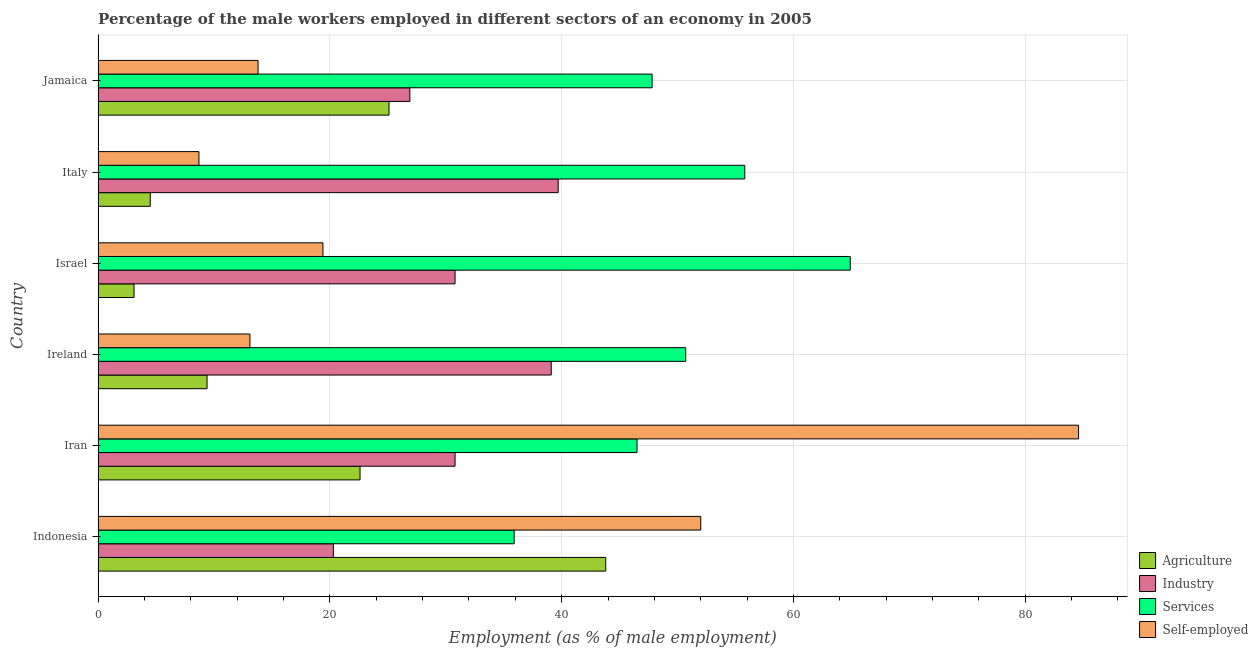How many different coloured bars are there?
Your answer should be very brief. 4. Are the number of bars per tick equal to the number of legend labels?
Ensure brevity in your answer.  Yes. How many bars are there on the 2nd tick from the bottom?
Provide a short and direct response. 4. What is the label of the 2nd group of bars from the top?
Give a very brief answer. Italy. In how many cases, is the number of bars for a given country not equal to the number of legend labels?
Give a very brief answer. 0. What is the percentage of male workers in services in Jamaica?
Keep it short and to the point. 47.8. Across all countries, what is the maximum percentage of male workers in agriculture?
Your answer should be very brief. 43.8. Across all countries, what is the minimum percentage of male workers in industry?
Give a very brief answer. 20.3. In which country was the percentage of male workers in industry maximum?
Offer a very short reply. Italy. In which country was the percentage of male workers in services minimum?
Make the answer very short. Indonesia. What is the total percentage of male workers in services in the graph?
Provide a short and direct response. 301.6. What is the difference between the percentage of male workers in agriculture in Indonesia and that in Iran?
Provide a short and direct response. 21.2. What is the difference between the percentage of male workers in agriculture in Iran and the percentage of male workers in services in Israel?
Give a very brief answer. -42.3. What is the average percentage of male workers in industry per country?
Your answer should be very brief. 31.27. What is the difference between the percentage of male workers in agriculture and percentage of self employed male workers in Iran?
Provide a succinct answer. -62. In how many countries, is the percentage of male workers in services greater than 52 %?
Make the answer very short. 2. What is the ratio of the percentage of male workers in services in Ireland to that in Israel?
Your answer should be very brief. 0.78. Is the difference between the percentage of male workers in agriculture in Indonesia and Jamaica greater than the difference between the percentage of male workers in industry in Indonesia and Jamaica?
Keep it short and to the point. Yes. What is the difference between the highest and the second highest percentage of male workers in industry?
Provide a succinct answer. 0.6. What is the difference between the highest and the lowest percentage of male workers in industry?
Provide a succinct answer. 19.4. What does the 4th bar from the top in Iran represents?
Keep it short and to the point. Agriculture. What does the 4th bar from the bottom in Jamaica represents?
Your answer should be very brief. Self-employed. Is it the case that in every country, the sum of the percentage of male workers in agriculture and percentage of male workers in industry is greater than the percentage of male workers in services?
Provide a succinct answer. No. How many bars are there?
Offer a terse response. 24. Are all the bars in the graph horizontal?
Give a very brief answer. Yes. What is the difference between two consecutive major ticks on the X-axis?
Give a very brief answer. 20. How many legend labels are there?
Ensure brevity in your answer.  4. What is the title of the graph?
Your response must be concise. Percentage of the male workers employed in different sectors of an economy in 2005. Does "Taxes on income" appear as one of the legend labels in the graph?
Your answer should be very brief. No. What is the label or title of the X-axis?
Provide a succinct answer. Employment (as % of male employment). What is the Employment (as % of male employment) in Agriculture in Indonesia?
Your answer should be very brief. 43.8. What is the Employment (as % of male employment) in Industry in Indonesia?
Make the answer very short. 20.3. What is the Employment (as % of male employment) of Services in Indonesia?
Keep it short and to the point. 35.9. What is the Employment (as % of male employment) in Self-employed in Indonesia?
Keep it short and to the point. 52. What is the Employment (as % of male employment) of Agriculture in Iran?
Offer a terse response. 22.6. What is the Employment (as % of male employment) of Industry in Iran?
Give a very brief answer. 30.8. What is the Employment (as % of male employment) in Services in Iran?
Your response must be concise. 46.5. What is the Employment (as % of male employment) in Self-employed in Iran?
Give a very brief answer. 84.6. What is the Employment (as % of male employment) of Agriculture in Ireland?
Offer a very short reply. 9.4. What is the Employment (as % of male employment) of Industry in Ireland?
Provide a succinct answer. 39.1. What is the Employment (as % of male employment) in Services in Ireland?
Ensure brevity in your answer.  50.7. What is the Employment (as % of male employment) of Self-employed in Ireland?
Provide a short and direct response. 13.1. What is the Employment (as % of male employment) in Agriculture in Israel?
Give a very brief answer. 3.1. What is the Employment (as % of male employment) in Industry in Israel?
Ensure brevity in your answer.  30.8. What is the Employment (as % of male employment) of Services in Israel?
Ensure brevity in your answer.  64.9. What is the Employment (as % of male employment) in Self-employed in Israel?
Your answer should be very brief. 19.4. What is the Employment (as % of male employment) of Agriculture in Italy?
Make the answer very short. 4.5. What is the Employment (as % of male employment) of Industry in Italy?
Your response must be concise. 39.7. What is the Employment (as % of male employment) in Services in Italy?
Your answer should be compact. 55.8. What is the Employment (as % of male employment) of Self-employed in Italy?
Offer a very short reply. 8.7. What is the Employment (as % of male employment) of Agriculture in Jamaica?
Offer a terse response. 25.1. What is the Employment (as % of male employment) in Industry in Jamaica?
Offer a terse response. 26.9. What is the Employment (as % of male employment) in Services in Jamaica?
Your answer should be compact. 47.8. What is the Employment (as % of male employment) in Self-employed in Jamaica?
Your answer should be compact. 13.8. Across all countries, what is the maximum Employment (as % of male employment) of Agriculture?
Give a very brief answer. 43.8. Across all countries, what is the maximum Employment (as % of male employment) in Industry?
Provide a short and direct response. 39.7. Across all countries, what is the maximum Employment (as % of male employment) of Services?
Ensure brevity in your answer.  64.9. Across all countries, what is the maximum Employment (as % of male employment) of Self-employed?
Your answer should be very brief. 84.6. Across all countries, what is the minimum Employment (as % of male employment) of Agriculture?
Ensure brevity in your answer.  3.1. Across all countries, what is the minimum Employment (as % of male employment) in Industry?
Provide a succinct answer. 20.3. Across all countries, what is the minimum Employment (as % of male employment) of Services?
Offer a very short reply. 35.9. Across all countries, what is the minimum Employment (as % of male employment) in Self-employed?
Offer a very short reply. 8.7. What is the total Employment (as % of male employment) in Agriculture in the graph?
Your response must be concise. 108.5. What is the total Employment (as % of male employment) in Industry in the graph?
Ensure brevity in your answer.  187.6. What is the total Employment (as % of male employment) of Services in the graph?
Keep it short and to the point. 301.6. What is the total Employment (as % of male employment) of Self-employed in the graph?
Keep it short and to the point. 191.6. What is the difference between the Employment (as % of male employment) in Agriculture in Indonesia and that in Iran?
Ensure brevity in your answer.  21.2. What is the difference between the Employment (as % of male employment) of Services in Indonesia and that in Iran?
Offer a terse response. -10.6. What is the difference between the Employment (as % of male employment) in Self-employed in Indonesia and that in Iran?
Keep it short and to the point. -32.6. What is the difference between the Employment (as % of male employment) of Agriculture in Indonesia and that in Ireland?
Ensure brevity in your answer.  34.4. What is the difference between the Employment (as % of male employment) of Industry in Indonesia and that in Ireland?
Ensure brevity in your answer.  -18.8. What is the difference between the Employment (as % of male employment) of Services in Indonesia and that in Ireland?
Give a very brief answer. -14.8. What is the difference between the Employment (as % of male employment) of Self-employed in Indonesia and that in Ireland?
Your answer should be compact. 38.9. What is the difference between the Employment (as % of male employment) of Agriculture in Indonesia and that in Israel?
Provide a succinct answer. 40.7. What is the difference between the Employment (as % of male employment) in Industry in Indonesia and that in Israel?
Give a very brief answer. -10.5. What is the difference between the Employment (as % of male employment) of Services in Indonesia and that in Israel?
Your answer should be very brief. -29. What is the difference between the Employment (as % of male employment) in Self-employed in Indonesia and that in Israel?
Your response must be concise. 32.6. What is the difference between the Employment (as % of male employment) of Agriculture in Indonesia and that in Italy?
Ensure brevity in your answer.  39.3. What is the difference between the Employment (as % of male employment) of Industry in Indonesia and that in Italy?
Offer a very short reply. -19.4. What is the difference between the Employment (as % of male employment) in Services in Indonesia and that in Italy?
Give a very brief answer. -19.9. What is the difference between the Employment (as % of male employment) of Self-employed in Indonesia and that in Italy?
Keep it short and to the point. 43.3. What is the difference between the Employment (as % of male employment) in Industry in Indonesia and that in Jamaica?
Ensure brevity in your answer.  -6.6. What is the difference between the Employment (as % of male employment) of Services in Indonesia and that in Jamaica?
Your answer should be very brief. -11.9. What is the difference between the Employment (as % of male employment) of Self-employed in Indonesia and that in Jamaica?
Ensure brevity in your answer.  38.2. What is the difference between the Employment (as % of male employment) of Agriculture in Iran and that in Ireland?
Your response must be concise. 13.2. What is the difference between the Employment (as % of male employment) of Industry in Iran and that in Ireland?
Keep it short and to the point. -8.3. What is the difference between the Employment (as % of male employment) in Services in Iran and that in Ireland?
Give a very brief answer. -4.2. What is the difference between the Employment (as % of male employment) of Self-employed in Iran and that in Ireland?
Offer a very short reply. 71.5. What is the difference between the Employment (as % of male employment) in Agriculture in Iran and that in Israel?
Offer a very short reply. 19.5. What is the difference between the Employment (as % of male employment) of Industry in Iran and that in Israel?
Make the answer very short. 0. What is the difference between the Employment (as % of male employment) in Services in Iran and that in Israel?
Give a very brief answer. -18.4. What is the difference between the Employment (as % of male employment) in Self-employed in Iran and that in Israel?
Provide a succinct answer. 65.2. What is the difference between the Employment (as % of male employment) of Industry in Iran and that in Italy?
Give a very brief answer. -8.9. What is the difference between the Employment (as % of male employment) of Self-employed in Iran and that in Italy?
Ensure brevity in your answer.  75.9. What is the difference between the Employment (as % of male employment) in Agriculture in Iran and that in Jamaica?
Offer a very short reply. -2.5. What is the difference between the Employment (as % of male employment) of Industry in Iran and that in Jamaica?
Your answer should be compact. 3.9. What is the difference between the Employment (as % of male employment) in Services in Iran and that in Jamaica?
Provide a short and direct response. -1.3. What is the difference between the Employment (as % of male employment) in Self-employed in Iran and that in Jamaica?
Your answer should be compact. 70.8. What is the difference between the Employment (as % of male employment) of Agriculture in Ireland and that in Israel?
Ensure brevity in your answer.  6.3. What is the difference between the Employment (as % of male employment) of Services in Ireland and that in Israel?
Give a very brief answer. -14.2. What is the difference between the Employment (as % of male employment) of Self-employed in Ireland and that in Israel?
Provide a short and direct response. -6.3. What is the difference between the Employment (as % of male employment) in Agriculture in Ireland and that in Italy?
Your answer should be compact. 4.9. What is the difference between the Employment (as % of male employment) in Agriculture in Ireland and that in Jamaica?
Your response must be concise. -15.7. What is the difference between the Employment (as % of male employment) in Services in Israel and that in Jamaica?
Provide a succinct answer. 17.1. What is the difference between the Employment (as % of male employment) of Self-employed in Israel and that in Jamaica?
Your answer should be compact. 5.6. What is the difference between the Employment (as % of male employment) of Agriculture in Italy and that in Jamaica?
Your answer should be compact. -20.6. What is the difference between the Employment (as % of male employment) in Agriculture in Indonesia and the Employment (as % of male employment) in Industry in Iran?
Your response must be concise. 13. What is the difference between the Employment (as % of male employment) of Agriculture in Indonesia and the Employment (as % of male employment) of Services in Iran?
Provide a short and direct response. -2.7. What is the difference between the Employment (as % of male employment) of Agriculture in Indonesia and the Employment (as % of male employment) of Self-employed in Iran?
Your response must be concise. -40.8. What is the difference between the Employment (as % of male employment) in Industry in Indonesia and the Employment (as % of male employment) in Services in Iran?
Give a very brief answer. -26.2. What is the difference between the Employment (as % of male employment) in Industry in Indonesia and the Employment (as % of male employment) in Self-employed in Iran?
Provide a short and direct response. -64.3. What is the difference between the Employment (as % of male employment) of Services in Indonesia and the Employment (as % of male employment) of Self-employed in Iran?
Offer a very short reply. -48.7. What is the difference between the Employment (as % of male employment) in Agriculture in Indonesia and the Employment (as % of male employment) in Industry in Ireland?
Make the answer very short. 4.7. What is the difference between the Employment (as % of male employment) of Agriculture in Indonesia and the Employment (as % of male employment) of Services in Ireland?
Provide a short and direct response. -6.9. What is the difference between the Employment (as % of male employment) of Agriculture in Indonesia and the Employment (as % of male employment) of Self-employed in Ireland?
Your answer should be very brief. 30.7. What is the difference between the Employment (as % of male employment) in Industry in Indonesia and the Employment (as % of male employment) in Services in Ireland?
Give a very brief answer. -30.4. What is the difference between the Employment (as % of male employment) in Services in Indonesia and the Employment (as % of male employment) in Self-employed in Ireland?
Provide a succinct answer. 22.8. What is the difference between the Employment (as % of male employment) of Agriculture in Indonesia and the Employment (as % of male employment) of Industry in Israel?
Your answer should be very brief. 13. What is the difference between the Employment (as % of male employment) of Agriculture in Indonesia and the Employment (as % of male employment) of Services in Israel?
Provide a succinct answer. -21.1. What is the difference between the Employment (as % of male employment) in Agriculture in Indonesia and the Employment (as % of male employment) in Self-employed in Israel?
Offer a terse response. 24.4. What is the difference between the Employment (as % of male employment) of Industry in Indonesia and the Employment (as % of male employment) of Services in Israel?
Provide a short and direct response. -44.6. What is the difference between the Employment (as % of male employment) of Agriculture in Indonesia and the Employment (as % of male employment) of Self-employed in Italy?
Give a very brief answer. 35.1. What is the difference between the Employment (as % of male employment) of Industry in Indonesia and the Employment (as % of male employment) of Services in Italy?
Offer a very short reply. -35.5. What is the difference between the Employment (as % of male employment) in Services in Indonesia and the Employment (as % of male employment) in Self-employed in Italy?
Ensure brevity in your answer.  27.2. What is the difference between the Employment (as % of male employment) of Industry in Indonesia and the Employment (as % of male employment) of Services in Jamaica?
Your answer should be very brief. -27.5. What is the difference between the Employment (as % of male employment) in Services in Indonesia and the Employment (as % of male employment) in Self-employed in Jamaica?
Provide a short and direct response. 22.1. What is the difference between the Employment (as % of male employment) of Agriculture in Iran and the Employment (as % of male employment) of Industry in Ireland?
Provide a succinct answer. -16.5. What is the difference between the Employment (as % of male employment) of Agriculture in Iran and the Employment (as % of male employment) of Services in Ireland?
Provide a short and direct response. -28.1. What is the difference between the Employment (as % of male employment) of Industry in Iran and the Employment (as % of male employment) of Services in Ireland?
Ensure brevity in your answer.  -19.9. What is the difference between the Employment (as % of male employment) in Industry in Iran and the Employment (as % of male employment) in Self-employed in Ireland?
Provide a succinct answer. 17.7. What is the difference between the Employment (as % of male employment) in Services in Iran and the Employment (as % of male employment) in Self-employed in Ireland?
Keep it short and to the point. 33.4. What is the difference between the Employment (as % of male employment) in Agriculture in Iran and the Employment (as % of male employment) in Services in Israel?
Provide a short and direct response. -42.3. What is the difference between the Employment (as % of male employment) in Agriculture in Iran and the Employment (as % of male employment) in Self-employed in Israel?
Give a very brief answer. 3.2. What is the difference between the Employment (as % of male employment) of Industry in Iran and the Employment (as % of male employment) of Services in Israel?
Ensure brevity in your answer.  -34.1. What is the difference between the Employment (as % of male employment) of Industry in Iran and the Employment (as % of male employment) of Self-employed in Israel?
Make the answer very short. 11.4. What is the difference between the Employment (as % of male employment) of Services in Iran and the Employment (as % of male employment) of Self-employed in Israel?
Offer a terse response. 27.1. What is the difference between the Employment (as % of male employment) in Agriculture in Iran and the Employment (as % of male employment) in Industry in Italy?
Your answer should be very brief. -17.1. What is the difference between the Employment (as % of male employment) of Agriculture in Iran and the Employment (as % of male employment) of Services in Italy?
Your answer should be compact. -33.2. What is the difference between the Employment (as % of male employment) of Industry in Iran and the Employment (as % of male employment) of Self-employed in Italy?
Ensure brevity in your answer.  22.1. What is the difference between the Employment (as % of male employment) in Services in Iran and the Employment (as % of male employment) in Self-employed in Italy?
Make the answer very short. 37.8. What is the difference between the Employment (as % of male employment) in Agriculture in Iran and the Employment (as % of male employment) in Services in Jamaica?
Make the answer very short. -25.2. What is the difference between the Employment (as % of male employment) of Agriculture in Iran and the Employment (as % of male employment) of Self-employed in Jamaica?
Your response must be concise. 8.8. What is the difference between the Employment (as % of male employment) of Industry in Iran and the Employment (as % of male employment) of Services in Jamaica?
Provide a succinct answer. -17. What is the difference between the Employment (as % of male employment) in Industry in Iran and the Employment (as % of male employment) in Self-employed in Jamaica?
Provide a succinct answer. 17. What is the difference between the Employment (as % of male employment) in Services in Iran and the Employment (as % of male employment) in Self-employed in Jamaica?
Ensure brevity in your answer.  32.7. What is the difference between the Employment (as % of male employment) in Agriculture in Ireland and the Employment (as % of male employment) in Industry in Israel?
Make the answer very short. -21.4. What is the difference between the Employment (as % of male employment) in Agriculture in Ireland and the Employment (as % of male employment) in Services in Israel?
Offer a very short reply. -55.5. What is the difference between the Employment (as % of male employment) of Agriculture in Ireland and the Employment (as % of male employment) of Self-employed in Israel?
Make the answer very short. -10. What is the difference between the Employment (as % of male employment) of Industry in Ireland and the Employment (as % of male employment) of Services in Israel?
Offer a terse response. -25.8. What is the difference between the Employment (as % of male employment) in Industry in Ireland and the Employment (as % of male employment) in Self-employed in Israel?
Give a very brief answer. 19.7. What is the difference between the Employment (as % of male employment) in Services in Ireland and the Employment (as % of male employment) in Self-employed in Israel?
Your response must be concise. 31.3. What is the difference between the Employment (as % of male employment) in Agriculture in Ireland and the Employment (as % of male employment) in Industry in Italy?
Provide a succinct answer. -30.3. What is the difference between the Employment (as % of male employment) in Agriculture in Ireland and the Employment (as % of male employment) in Services in Italy?
Give a very brief answer. -46.4. What is the difference between the Employment (as % of male employment) of Industry in Ireland and the Employment (as % of male employment) of Services in Italy?
Offer a terse response. -16.7. What is the difference between the Employment (as % of male employment) of Industry in Ireland and the Employment (as % of male employment) of Self-employed in Italy?
Give a very brief answer. 30.4. What is the difference between the Employment (as % of male employment) of Agriculture in Ireland and the Employment (as % of male employment) of Industry in Jamaica?
Ensure brevity in your answer.  -17.5. What is the difference between the Employment (as % of male employment) of Agriculture in Ireland and the Employment (as % of male employment) of Services in Jamaica?
Provide a succinct answer. -38.4. What is the difference between the Employment (as % of male employment) of Industry in Ireland and the Employment (as % of male employment) of Self-employed in Jamaica?
Ensure brevity in your answer.  25.3. What is the difference between the Employment (as % of male employment) in Services in Ireland and the Employment (as % of male employment) in Self-employed in Jamaica?
Provide a succinct answer. 36.9. What is the difference between the Employment (as % of male employment) in Agriculture in Israel and the Employment (as % of male employment) in Industry in Italy?
Offer a terse response. -36.6. What is the difference between the Employment (as % of male employment) in Agriculture in Israel and the Employment (as % of male employment) in Services in Italy?
Make the answer very short. -52.7. What is the difference between the Employment (as % of male employment) in Agriculture in Israel and the Employment (as % of male employment) in Self-employed in Italy?
Ensure brevity in your answer.  -5.6. What is the difference between the Employment (as % of male employment) in Industry in Israel and the Employment (as % of male employment) in Services in Italy?
Your response must be concise. -25. What is the difference between the Employment (as % of male employment) of Industry in Israel and the Employment (as % of male employment) of Self-employed in Italy?
Your answer should be compact. 22.1. What is the difference between the Employment (as % of male employment) in Services in Israel and the Employment (as % of male employment) in Self-employed in Italy?
Your response must be concise. 56.2. What is the difference between the Employment (as % of male employment) of Agriculture in Israel and the Employment (as % of male employment) of Industry in Jamaica?
Give a very brief answer. -23.8. What is the difference between the Employment (as % of male employment) in Agriculture in Israel and the Employment (as % of male employment) in Services in Jamaica?
Make the answer very short. -44.7. What is the difference between the Employment (as % of male employment) of Agriculture in Israel and the Employment (as % of male employment) of Self-employed in Jamaica?
Make the answer very short. -10.7. What is the difference between the Employment (as % of male employment) in Industry in Israel and the Employment (as % of male employment) in Self-employed in Jamaica?
Your response must be concise. 17. What is the difference between the Employment (as % of male employment) of Services in Israel and the Employment (as % of male employment) of Self-employed in Jamaica?
Keep it short and to the point. 51.1. What is the difference between the Employment (as % of male employment) in Agriculture in Italy and the Employment (as % of male employment) in Industry in Jamaica?
Ensure brevity in your answer.  -22.4. What is the difference between the Employment (as % of male employment) in Agriculture in Italy and the Employment (as % of male employment) in Services in Jamaica?
Make the answer very short. -43.3. What is the difference between the Employment (as % of male employment) in Industry in Italy and the Employment (as % of male employment) in Self-employed in Jamaica?
Keep it short and to the point. 25.9. What is the difference between the Employment (as % of male employment) of Services in Italy and the Employment (as % of male employment) of Self-employed in Jamaica?
Provide a succinct answer. 42. What is the average Employment (as % of male employment) of Agriculture per country?
Your answer should be compact. 18.08. What is the average Employment (as % of male employment) of Industry per country?
Offer a terse response. 31.27. What is the average Employment (as % of male employment) in Services per country?
Your answer should be very brief. 50.27. What is the average Employment (as % of male employment) in Self-employed per country?
Keep it short and to the point. 31.93. What is the difference between the Employment (as % of male employment) of Agriculture and Employment (as % of male employment) of Industry in Indonesia?
Your answer should be very brief. 23.5. What is the difference between the Employment (as % of male employment) of Agriculture and Employment (as % of male employment) of Services in Indonesia?
Keep it short and to the point. 7.9. What is the difference between the Employment (as % of male employment) of Agriculture and Employment (as % of male employment) of Self-employed in Indonesia?
Offer a very short reply. -8.2. What is the difference between the Employment (as % of male employment) in Industry and Employment (as % of male employment) in Services in Indonesia?
Your answer should be compact. -15.6. What is the difference between the Employment (as % of male employment) of Industry and Employment (as % of male employment) of Self-employed in Indonesia?
Provide a succinct answer. -31.7. What is the difference between the Employment (as % of male employment) in Services and Employment (as % of male employment) in Self-employed in Indonesia?
Offer a very short reply. -16.1. What is the difference between the Employment (as % of male employment) of Agriculture and Employment (as % of male employment) of Industry in Iran?
Offer a very short reply. -8.2. What is the difference between the Employment (as % of male employment) of Agriculture and Employment (as % of male employment) of Services in Iran?
Your answer should be very brief. -23.9. What is the difference between the Employment (as % of male employment) of Agriculture and Employment (as % of male employment) of Self-employed in Iran?
Your answer should be very brief. -62. What is the difference between the Employment (as % of male employment) in Industry and Employment (as % of male employment) in Services in Iran?
Provide a short and direct response. -15.7. What is the difference between the Employment (as % of male employment) of Industry and Employment (as % of male employment) of Self-employed in Iran?
Ensure brevity in your answer.  -53.8. What is the difference between the Employment (as % of male employment) in Services and Employment (as % of male employment) in Self-employed in Iran?
Provide a succinct answer. -38.1. What is the difference between the Employment (as % of male employment) of Agriculture and Employment (as % of male employment) of Industry in Ireland?
Your answer should be very brief. -29.7. What is the difference between the Employment (as % of male employment) in Agriculture and Employment (as % of male employment) in Services in Ireland?
Provide a short and direct response. -41.3. What is the difference between the Employment (as % of male employment) in Industry and Employment (as % of male employment) in Self-employed in Ireland?
Keep it short and to the point. 26. What is the difference between the Employment (as % of male employment) in Services and Employment (as % of male employment) in Self-employed in Ireland?
Your answer should be very brief. 37.6. What is the difference between the Employment (as % of male employment) in Agriculture and Employment (as % of male employment) in Industry in Israel?
Offer a very short reply. -27.7. What is the difference between the Employment (as % of male employment) in Agriculture and Employment (as % of male employment) in Services in Israel?
Your answer should be compact. -61.8. What is the difference between the Employment (as % of male employment) in Agriculture and Employment (as % of male employment) in Self-employed in Israel?
Keep it short and to the point. -16.3. What is the difference between the Employment (as % of male employment) in Industry and Employment (as % of male employment) in Services in Israel?
Offer a very short reply. -34.1. What is the difference between the Employment (as % of male employment) of Services and Employment (as % of male employment) of Self-employed in Israel?
Make the answer very short. 45.5. What is the difference between the Employment (as % of male employment) in Agriculture and Employment (as % of male employment) in Industry in Italy?
Provide a short and direct response. -35.2. What is the difference between the Employment (as % of male employment) in Agriculture and Employment (as % of male employment) in Services in Italy?
Give a very brief answer. -51.3. What is the difference between the Employment (as % of male employment) of Agriculture and Employment (as % of male employment) of Self-employed in Italy?
Offer a very short reply. -4.2. What is the difference between the Employment (as % of male employment) in Industry and Employment (as % of male employment) in Services in Italy?
Provide a short and direct response. -16.1. What is the difference between the Employment (as % of male employment) in Industry and Employment (as % of male employment) in Self-employed in Italy?
Make the answer very short. 31. What is the difference between the Employment (as % of male employment) in Services and Employment (as % of male employment) in Self-employed in Italy?
Offer a very short reply. 47.1. What is the difference between the Employment (as % of male employment) in Agriculture and Employment (as % of male employment) in Industry in Jamaica?
Ensure brevity in your answer.  -1.8. What is the difference between the Employment (as % of male employment) in Agriculture and Employment (as % of male employment) in Services in Jamaica?
Your answer should be very brief. -22.7. What is the difference between the Employment (as % of male employment) in Agriculture and Employment (as % of male employment) in Self-employed in Jamaica?
Ensure brevity in your answer.  11.3. What is the difference between the Employment (as % of male employment) of Industry and Employment (as % of male employment) of Services in Jamaica?
Keep it short and to the point. -20.9. What is the difference between the Employment (as % of male employment) of Industry and Employment (as % of male employment) of Self-employed in Jamaica?
Your response must be concise. 13.1. What is the difference between the Employment (as % of male employment) of Services and Employment (as % of male employment) of Self-employed in Jamaica?
Your answer should be compact. 34. What is the ratio of the Employment (as % of male employment) of Agriculture in Indonesia to that in Iran?
Your response must be concise. 1.94. What is the ratio of the Employment (as % of male employment) of Industry in Indonesia to that in Iran?
Make the answer very short. 0.66. What is the ratio of the Employment (as % of male employment) in Services in Indonesia to that in Iran?
Give a very brief answer. 0.77. What is the ratio of the Employment (as % of male employment) of Self-employed in Indonesia to that in Iran?
Keep it short and to the point. 0.61. What is the ratio of the Employment (as % of male employment) in Agriculture in Indonesia to that in Ireland?
Keep it short and to the point. 4.66. What is the ratio of the Employment (as % of male employment) of Industry in Indonesia to that in Ireland?
Ensure brevity in your answer.  0.52. What is the ratio of the Employment (as % of male employment) in Services in Indonesia to that in Ireland?
Give a very brief answer. 0.71. What is the ratio of the Employment (as % of male employment) in Self-employed in Indonesia to that in Ireland?
Make the answer very short. 3.97. What is the ratio of the Employment (as % of male employment) of Agriculture in Indonesia to that in Israel?
Your answer should be compact. 14.13. What is the ratio of the Employment (as % of male employment) of Industry in Indonesia to that in Israel?
Keep it short and to the point. 0.66. What is the ratio of the Employment (as % of male employment) in Services in Indonesia to that in Israel?
Offer a terse response. 0.55. What is the ratio of the Employment (as % of male employment) of Self-employed in Indonesia to that in Israel?
Your answer should be compact. 2.68. What is the ratio of the Employment (as % of male employment) in Agriculture in Indonesia to that in Italy?
Give a very brief answer. 9.73. What is the ratio of the Employment (as % of male employment) in Industry in Indonesia to that in Italy?
Provide a succinct answer. 0.51. What is the ratio of the Employment (as % of male employment) in Services in Indonesia to that in Italy?
Keep it short and to the point. 0.64. What is the ratio of the Employment (as % of male employment) in Self-employed in Indonesia to that in Italy?
Provide a short and direct response. 5.98. What is the ratio of the Employment (as % of male employment) in Agriculture in Indonesia to that in Jamaica?
Make the answer very short. 1.75. What is the ratio of the Employment (as % of male employment) in Industry in Indonesia to that in Jamaica?
Your response must be concise. 0.75. What is the ratio of the Employment (as % of male employment) in Services in Indonesia to that in Jamaica?
Ensure brevity in your answer.  0.75. What is the ratio of the Employment (as % of male employment) of Self-employed in Indonesia to that in Jamaica?
Offer a very short reply. 3.77. What is the ratio of the Employment (as % of male employment) of Agriculture in Iran to that in Ireland?
Give a very brief answer. 2.4. What is the ratio of the Employment (as % of male employment) of Industry in Iran to that in Ireland?
Your answer should be compact. 0.79. What is the ratio of the Employment (as % of male employment) of Services in Iran to that in Ireland?
Provide a succinct answer. 0.92. What is the ratio of the Employment (as % of male employment) of Self-employed in Iran to that in Ireland?
Your answer should be compact. 6.46. What is the ratio of the Employment (as % of male employment) of Agriculture in Iran to that in Israel?
Your response must be concise. 7.29. What is the ratio of the Employment (as % of male employment) in Services in Iran to that in Israel?
Ensure brevity in your answer.  0.72. What is the ratio of the Employment (as % of male employment) in Self-employed in Iran to that in Israel?
Ensure brevity in your answer.  4.36. What is the ratio of the Employment (as % of male employment) of Agriculture in Iran to that in Italy?
Keep it short and to the point. 5.02. What is the ratio of the Employment (as % of male employment) of Industry in Iran to that in Italy?
Your response must be concise. 0.78. What is the ratio of the Employment (as % of male employment) of Self-employed in Iran to that in Italy?
Your response must be concise. 9.72. What is the ratio of the Employment (as % of male employment) of Agriculture in Iran to that in Jamaica?
Offer a terse response. 0.9. What is the ratio of the Employment (as % of male employment) in Industry in Iran to that in Jamaica?
Keep it short and to the point. 1.15. What is the ratio of the Employment (as % of male employment) of Services in Iran to that in Jamaica?
Give a very brief answer. 0.97. What is the ratio of the Employment (as % of male employment) of Self-employed in Iran to that in Jamaica?
Offer a very short reply. 6.13. What is the ratio of the Employment (as % of male employment) in Agriculture in Ireland to that in Israel?
Provide a succinct answer. 3.03. What is the ratio of the Employment (as % of male employment) in Industry in Ireland to that in Israel?
Offer a terse response. 1.27. What is the ratio of the Employment (as % of male employment) of Services in Ireland to that in Israel?
Provide a short and direct response. 0.78. What is the ratio of the Employment (as % of male employment) of Self-employed in Ireland to that in Israel?
Ensure brevity in your answer.  0.68. What is the ratio of the Employment (as % of male employment) in Agriculture in Ireland to that in Italy?
Make the answer very short. 2.09. What is the ratio of the Employment (as % of male employment) in Industry in Ireland to that in Italy?
Your answer should be compact. 0.98. What is the ratio of the Employment (as % of male employment) in Services in Ireland to that in Italy?
Give a very brief answer. 0.91. What is the ratio of the Employment (as % of male employment) of Self-employed in Ireland to that in Italy?
Your answer should be very brief. 1.51. What is the ratio of the Employment (as % of male employment) of Agriculture in Ireland to that in Jamaica?
Provide a succinct answer. 0.37. What is the ratio of the Employment (as % of male employment) in Industry in Ireland to that in Jamaica?
Your response must be concise. 1.45. What is the ratio of the Employment (as % of male employment) of Services in Ireland to that in Jamaica?
Offer a very short reply. 1.06. What is the ratio of the Employment (as % of male employment) of Self-employed in Ireland to that in Jamaica?
Provide a succinct answer. 0.95. What is the ratio of the Employment (as % of male employment) of Agriculture in Israel to that in Italy?
Provide a short and direct response. 0.69. What is the ratio of the Employment (as % of male employment) in Industry in Israel to that in Italy?
Keep it short and to the point. 0.78. What is the ratio of the Employment (as % of male employment) in Services in Israel to that in Italy?
Keep it short and to the point. 1.16. What is the ratio of the Employment (as % of male employment) in Self-employed in Israel to that in Italy?
Give a very brief answer. 2.23. What is the ratio of the Employment (as % of male employment) of Agriculture in Israel to that in Jamaica?
Offer a very short reply. 0.12. What is the ratio of the Employment (as % of male employment) in Industry in Israel to that in Jamaica?
Offer a terse response. 1.15. What is the ratio of the Employment (as % of male employment) of Services in Israel to that in Jamaica?
Make the answer very short. 1.36. What is the ratio of the Employment (as % of male employment) of Self-employed in Israel to that in Jamaica?
Provide a short and direct response. 1.41. What is the ratio of the Employment (as % of male employment) in Agriculture in Italy to that in Jamaica?
Provide a succinct answer. 0.18. What is the ratio of the Employment (as % of male employment) of Industry in Italy to that in Jamaica?
Keep it short and to the point. 1.48. What is the ratio of the Employment (as % of male employment) of Services in Italy to that in Jamaica?
Your answer should be compact. 1.17. What is the ratio of the Employment (as % of male employment) in Self-employed in Italy to that in Jamaica?
Make the answer very short. 0.63. What is the difference between the highest and the second highest Employment (as % of male employment) in Self-employed?
Make the answer very short. 32.6. What is the difference between the highest and the lowest Employment (as % of male employment) in Agriculture?
Provide a succinct answer. 40.7. What is the difference between the highest and the lowest Employment (as % of male employment) in Industry?
Keep it short and to the point. 19.4. What is the difference between the highest and the lowest Employment (as % of male employment) of Self-employed?
Keep it short and to the point. 75.9. 